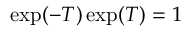<formula> <loc_0><loc_0><loc_500><loc_500>\exp ( - T ) \exp ( T ) = 1</formula> 